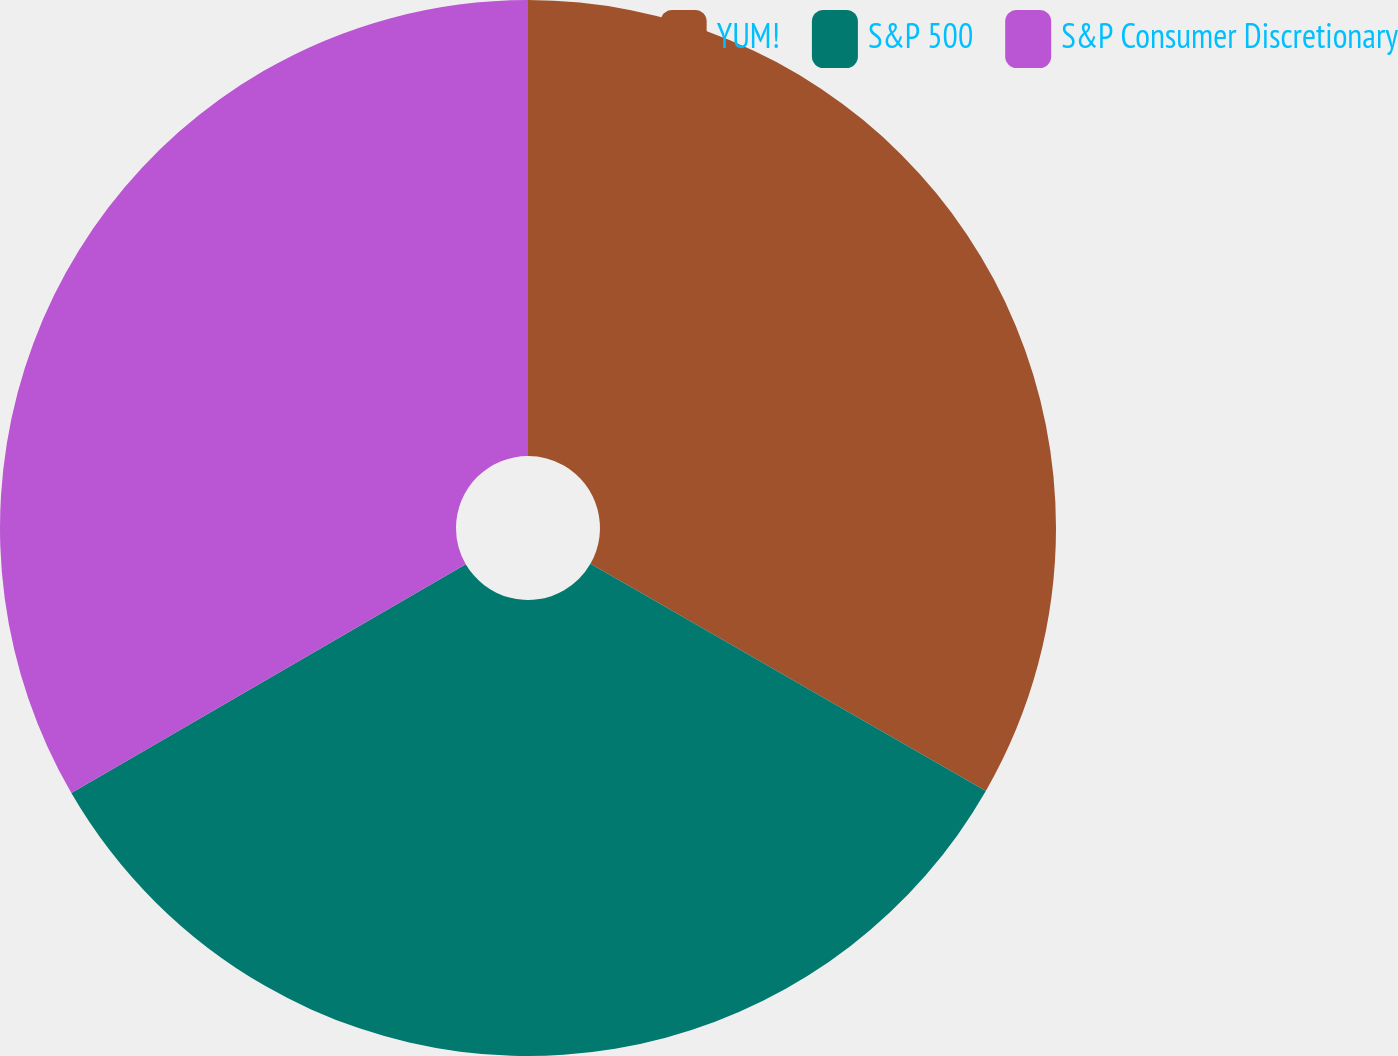Convert chart. <chart><loc_0><loc_0><loc_500><loc_500><pie_chart><fcel>YUM!<fcel>S&P 500<fcel>S&P Consumer Discretionary<nl><fcel>33.3%<fcel>33.33%<fcel>33.37%<nl></chart> 